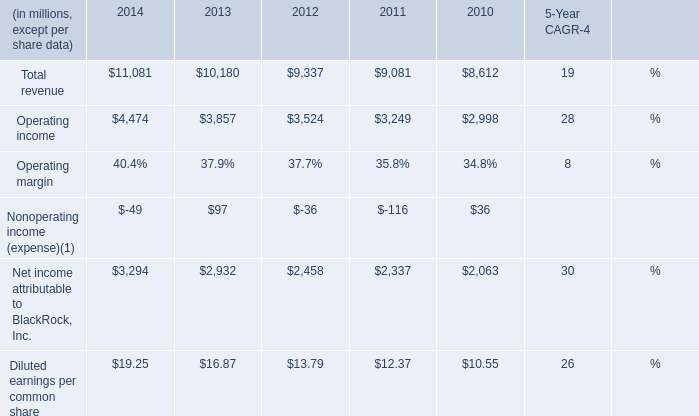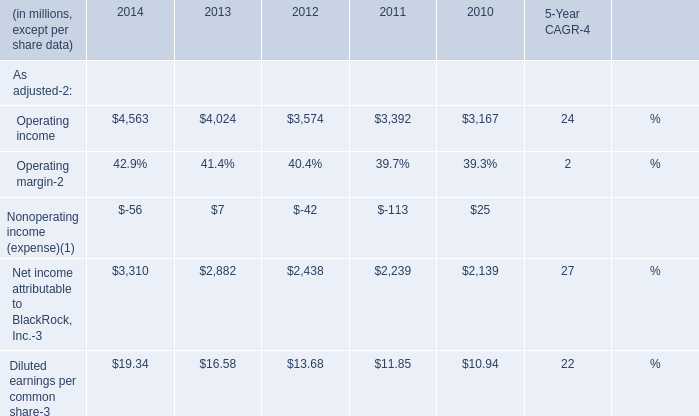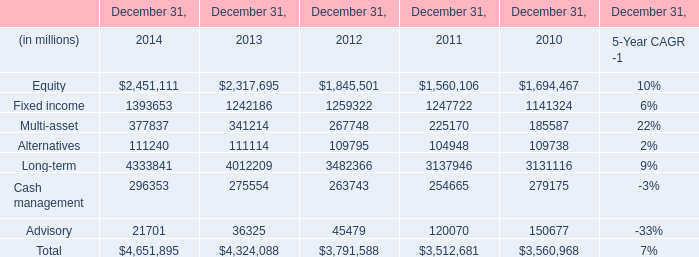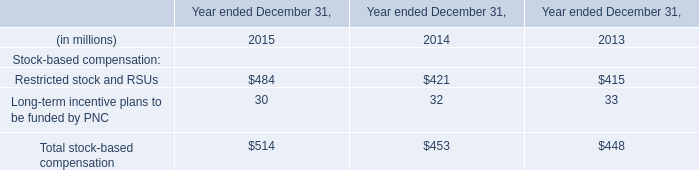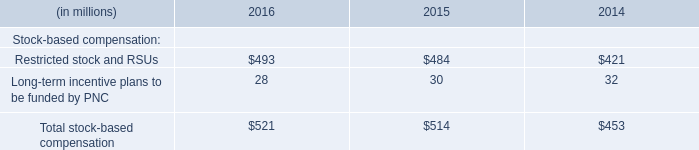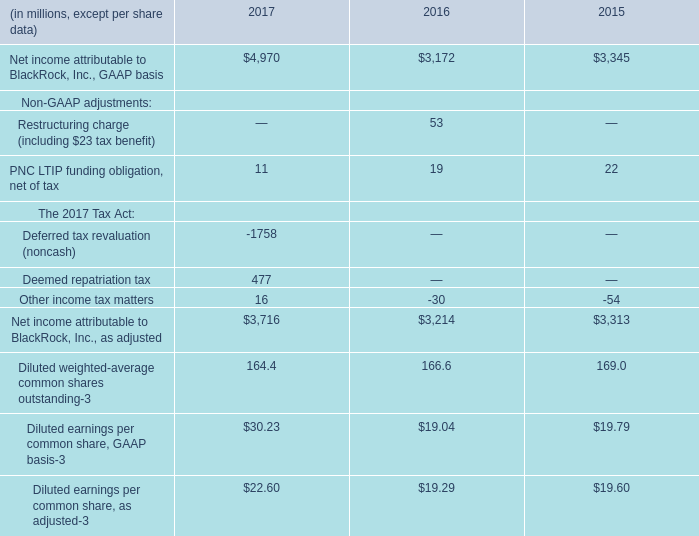What's the current growth rate of Operating income? (in million) 
Computations: ((4474 - 3857) / 3857)
Answer: 0.15997. 